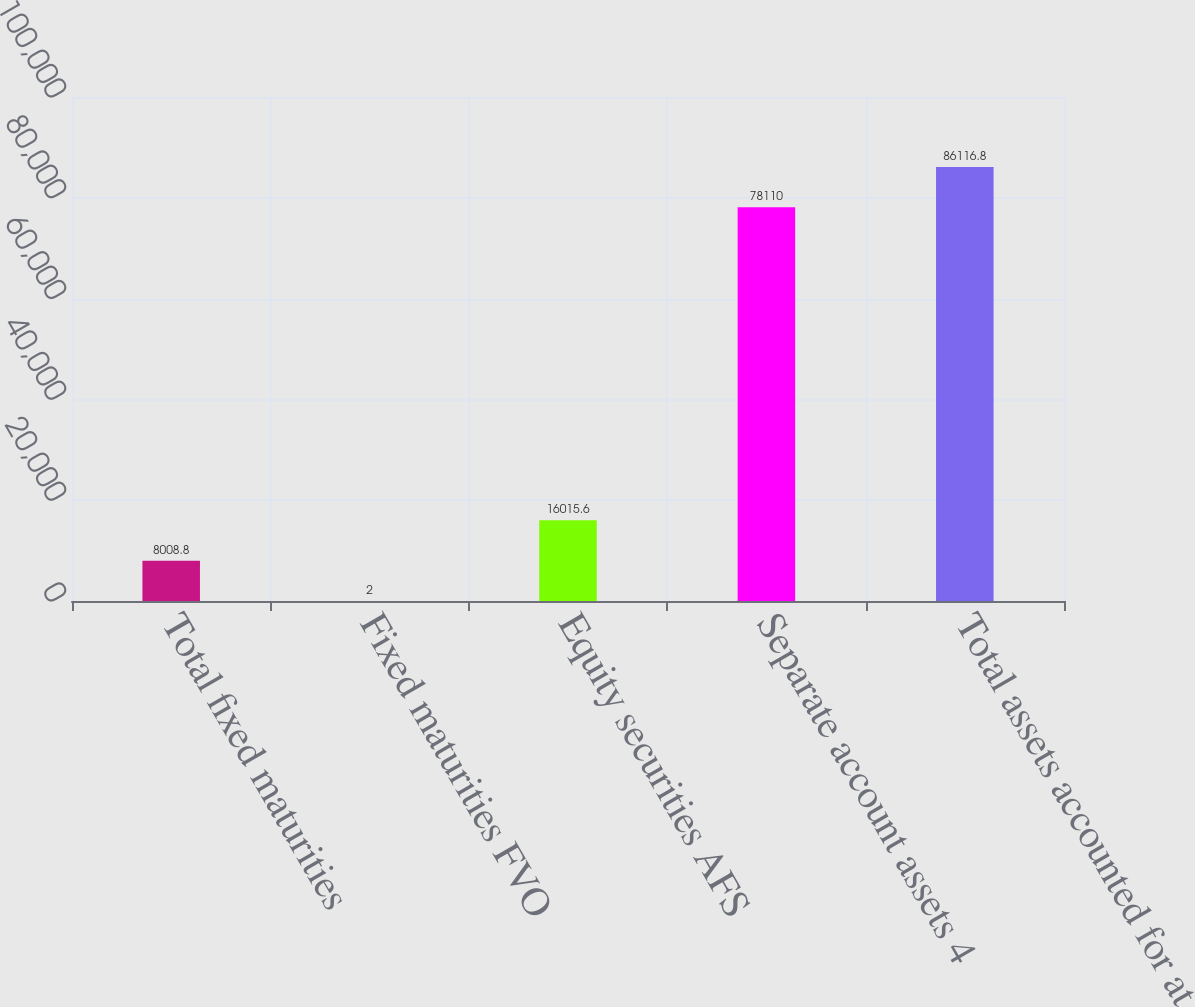Convert chart. <chart><loc_0><loc_0><loc_500><loc_500><bar_chart><fcel>Total fixed maturities<fcel>Fixed maturities FVO<fcel>Equity securities AFS<fcel>Separate account assets 4<fcel>Total assets accounted for at<nl><fcel>8008.8<fcel>2<fcel>16015.6<fcel>78110<fcel>86116.8<nl></chart> 